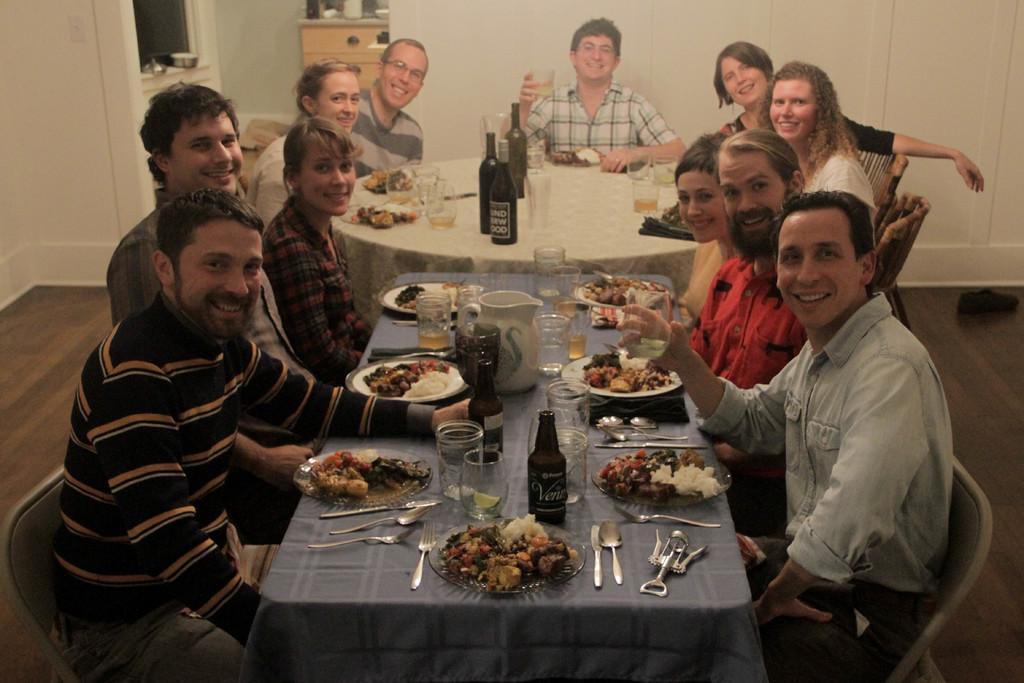How would you summarize this image in a sentence or two? In this picture we can see glasses, bottles, a jug, some food items in the plates, spoons, forks and other objects on the tables. We can see a few people sitting on the chairs. There are some objects visible on a shelf. We can see other objects on a desk. There are other objects. 